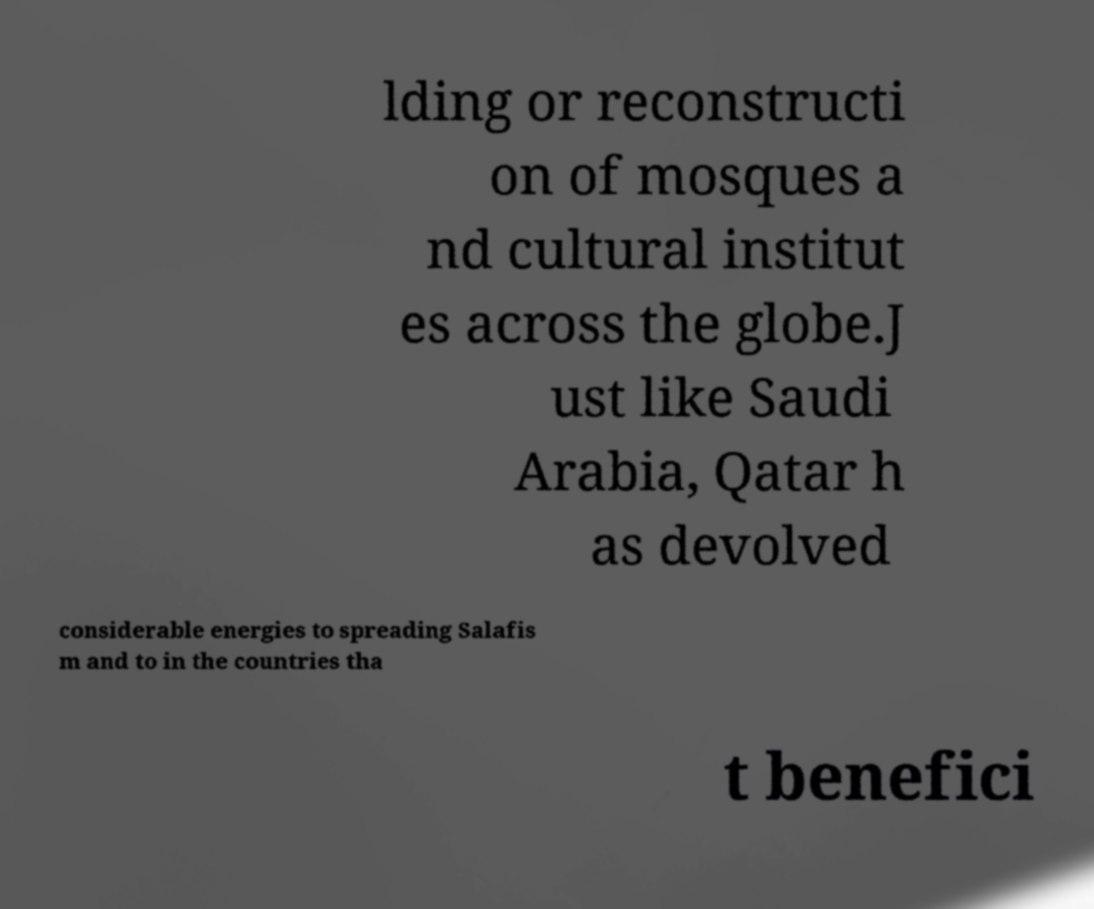What messages or text are displayed in this image? I need them in a readable, typed format. lding or reconstructi on of mosques a nd cultural institut es across the globe.J ust like Saudi Arabia, Qatar h as devolved considerable energies to spreading Salafis m and to in the countries tha t benefici 